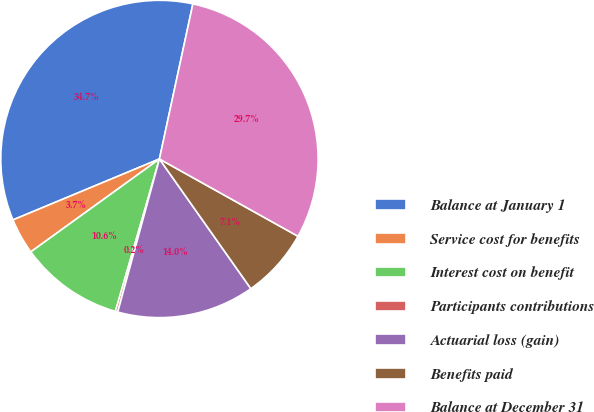Convert chart. <chart><loc_0><loc_0><loc_500><loc_500><pie_chart><fcel>Balance at January 1<fcel>Service cost for benefits<fcel>Interest cost on benefit<fcel>Participants contributions<fcel>Actuarial loss (gain)<fcel>Benefits paid<fcel>Balance at December 31<nl><fcel>34.66%<fcel>3.68%<fcel>10.57%<fcel>0.24%<fcel>14.01%<fcel>7.13%<fcel>29.72%<nl></chart> 